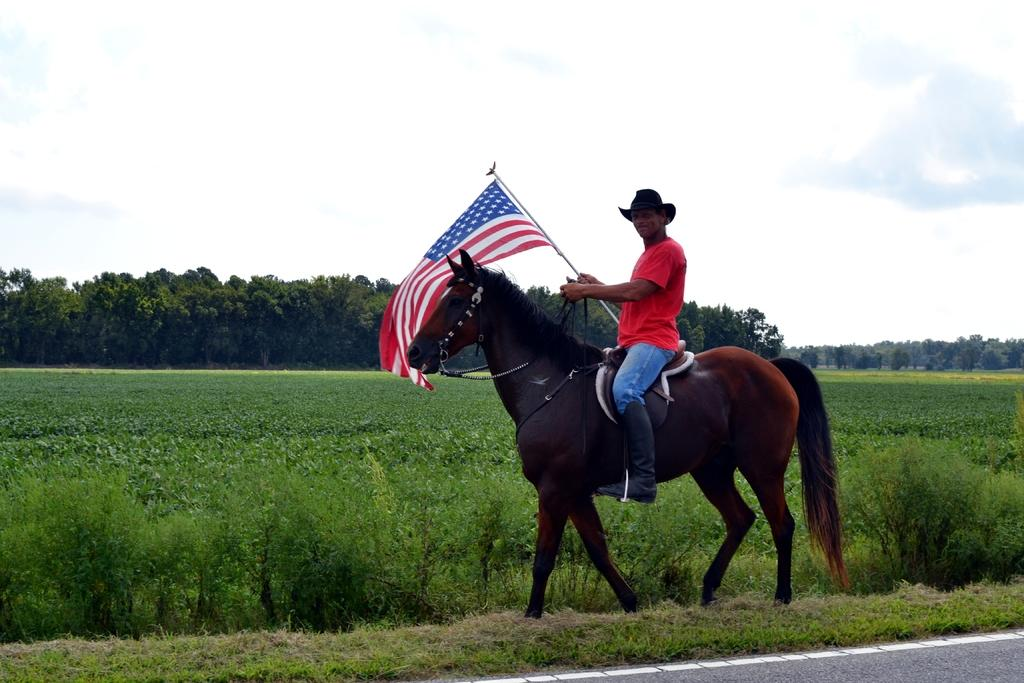What animal is in the image? There is a brown horse in the image. Who is on the horse? A man is sitting on the horse. What is the man wearing? The man is wearing a red t-shirt. What is the man holding? The man is holding an American flag. What can be seen in the background of the image? There is a grass lawn and trees in the background. What story is the duck telling with its feet in the image? There is no duck present in the image, so it is not possible to determine what story its feet might be telling. 